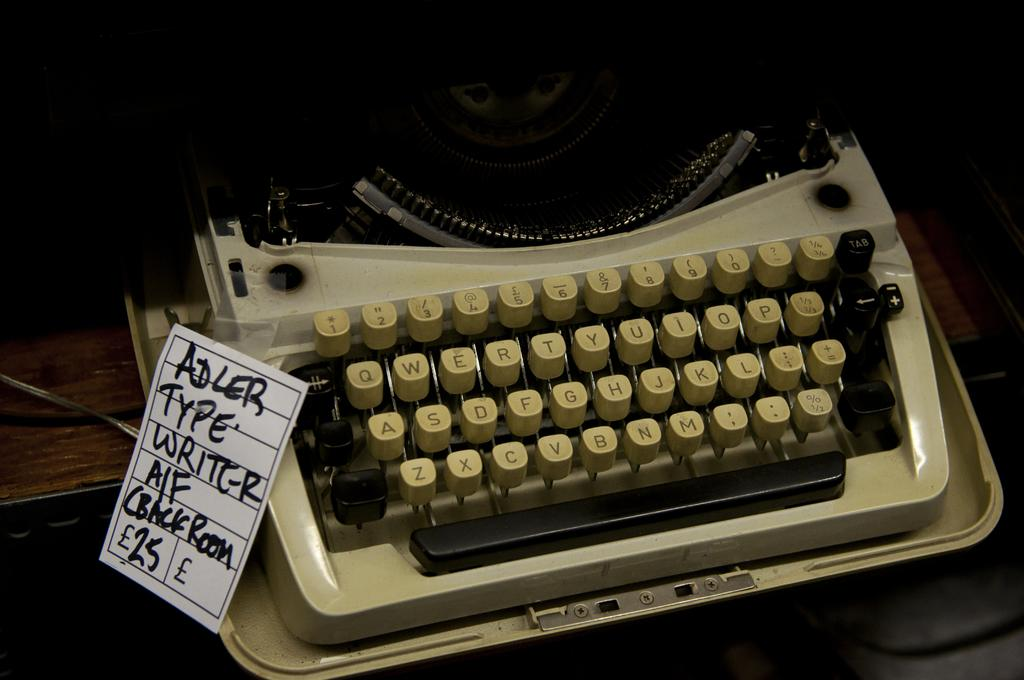<image>
Write a terse but informative summary of the picture. A manual typewriter for sale is made by Adler. 